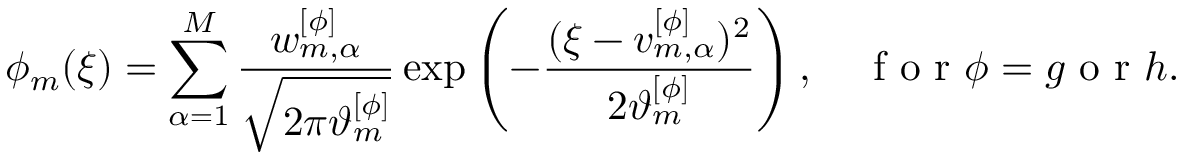Convert formula to latex. <formula><loc_0><loc_0><loc_500><loc_500>\phi _ { m } ( \xi ) = \sum _ { \alpha = 1 } ^ { M } \frac { w _ { m , \alpha } ^ { [ \phi ] } } { \sqrt { 2 \pi \vartheta _ { m } ^ { [ \phi ] } } } \exp \left ( - \frac { ( \xi - v _ { m , \alpha } ^ { [ \phi ] } ) ^ { 2 } } { 2 \vartheta _ { m } ^ { [ \phi ] } } \right ) , \quad f o r \phi = g o r h .</formula> 